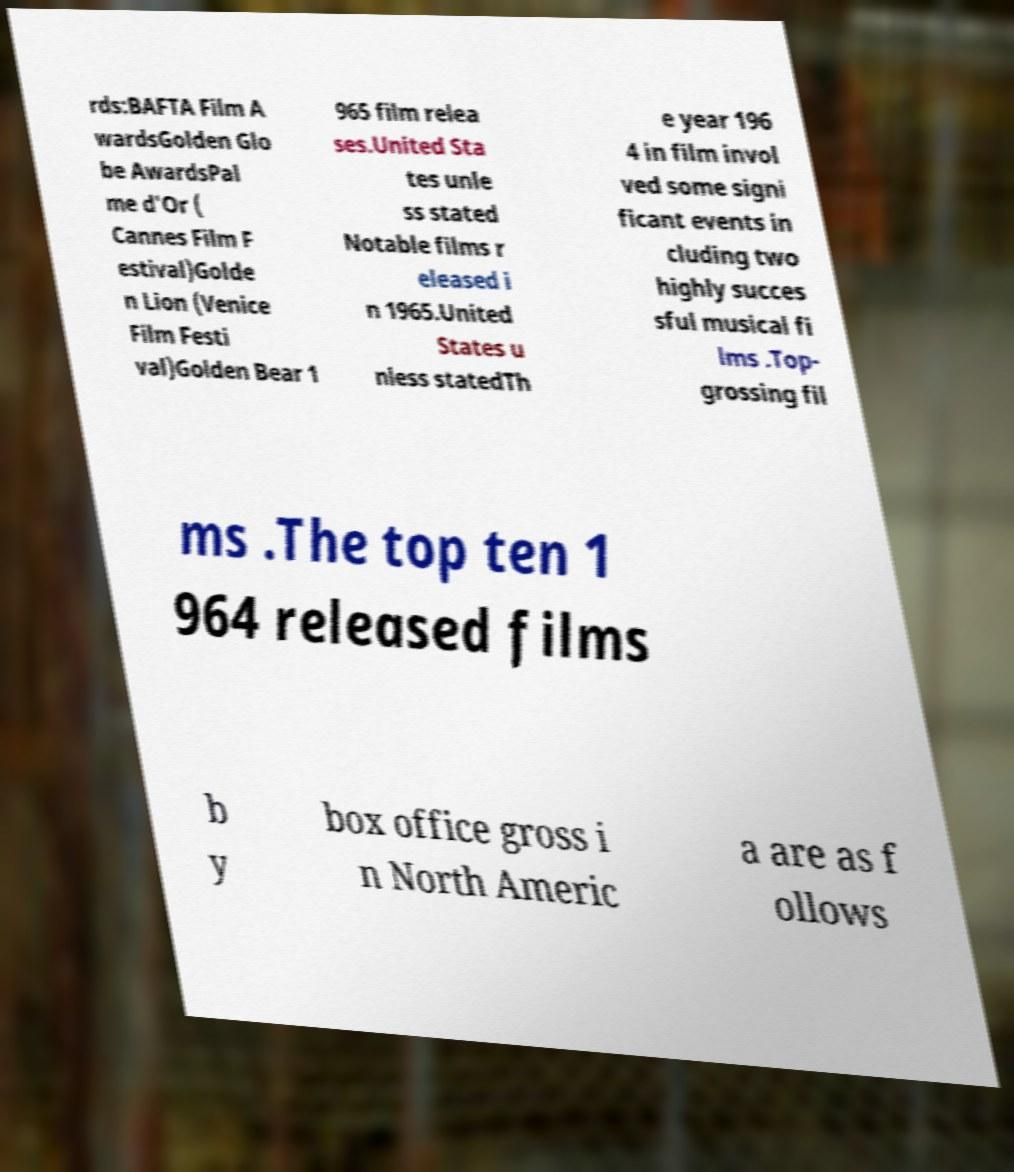Please read and relay the text visible in this image. What does it say? rds:BAFTA Film A wardsGolden Glo be AwardsPal me d'Or ( Cannes Film F estival)Golde n Lion (Venice Film Festi val)Golden Bear 1 965 film relea ses.United Sta tes unle ss stated Notable films r eleased i n 1965.United States u nless statedTh e year 196 4 in film invol ved some signi ficant events in cluding two highly succes sful musical fi lms .Top- grossing fil ms .The top ten 1 964 released films b y box office gross i n North Americ a are as f ollows 